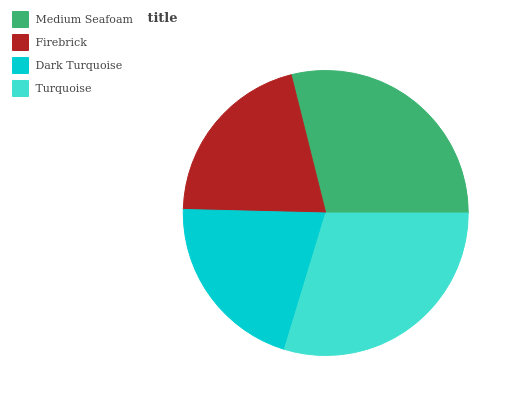Is Dark Turquoise the minimum?
Answer yes or no. Yes. Is Turquoise the maximum?
Answer yes or no. Yes. Is Firebrick the minimum?
Answer yes or no. No. Is Firebrick the maximum?
Answer yes or no. No. Is Medium Seafoam greater than Firebrick?
Answer yes or no. Yes. Is Firebrick less than Medium Seafoam?
Answer yes or no. Yes. Is Firebrick greater than Medium Seafoam?
Answer yes or no. No. Is Medium Seafoam less than Firebrick?
Answer yes or no. No. Is Medium Seafoam the high median?
Answer yes or no. Yes. Is Firebrick the low median?
Answer yes or no. Yes. Is Dark Turquoise the high median?
Answer yes or no. No. Is Medium Seafoam the low median?
Answer yes or no. No. 